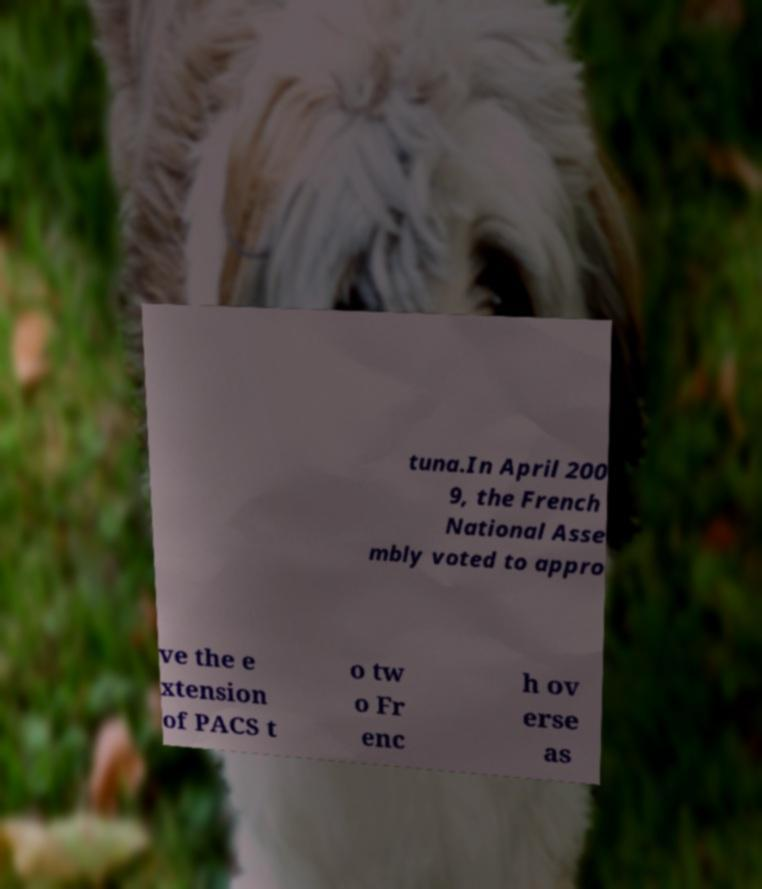Please identify and transcribe the text found in this image. tuna.In April 200 9, the French National Asse mbly voted to appro ve the e xtension of PACS t o tw o Fr enc h ov erse as 